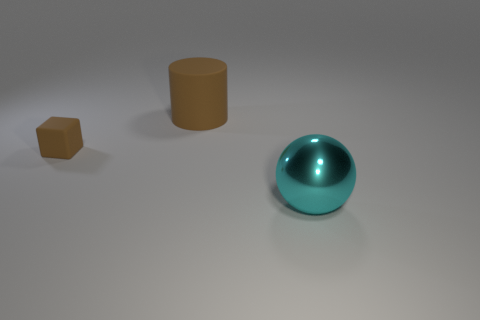Is there another big cyan thing of the same shape as the big cyan shiny thing?
Your response must be concise. No. Are there the same number of large things that are behind the small matte object and big cyan things?
Provide a short and direct response. Yes. What material is the brown thing that is to the left of the big object that is behind the metallic object made of?
Give a very brief answer. Rubber. The cyan metallic object has what shape?
Give a very brief answer. Sphere. Is the number of tiny cubes that are right of the large brown cylinder the same as the number of brown matte cylinders behind the big cyan metallic object?
Provide a succinct answer. No. Do the rubber cylinder that is behind the small brown matte block and the matte thing that is in front of the large matte thing have the same color?
Offer a very short reply. Yes. Are there more big cyan objects to the right of the tiny brown object than tiny green metal cubes?
Provide a succinct answer. Yes. The big thing that is the same material as the tiny brown block is what shape?
Offer a very short reply. Cylinder. There is a brown rubber thing that is behind the block; is its size the same as the big metal object?
Give a very brief answer. Yes. There is a big thing on the left side of the object that is in front of the small block; what is its shape?
Provide a succinct answer. Cylinder. 